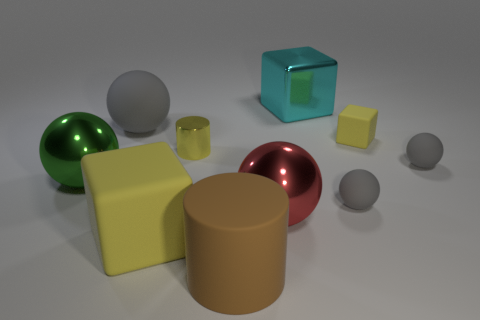Subtract all blue cubes. How many gray spheres are left? 3 Subtract all big shiny spheres. How many spheres are left? 3 Subtract 1 cubes. How many cubes are left? 2 Subtract all red balls. How many balls are left? 4 Subtract all brown spheres. Subtract all cyan cylinders. How many spheres are left? 5 Subtract all cylinders. How many objects are left? 8 Subtract all objects. Subtract all big brown balls. How many objects are left? 0 Add 5 green objects. How many green objects are left? 6 Add 2 small rubber spheres. How many small rubber spheres exist? 4 Subtract 0 blue balls. How many objects are left? 10 